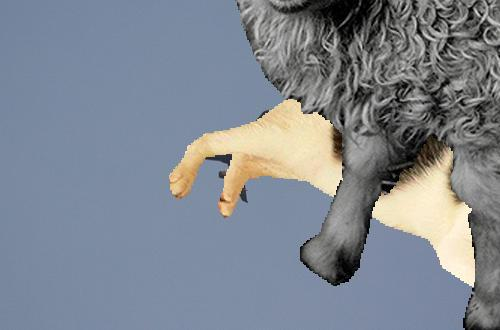What message might the creator be trying to convey with this image? Through this hybrid image of a sheep with hands for hooves, the creator might be evoking thoughts about genetic manipulation, the blending of species, or perhaps a humorous take on the phrase 'pulling the wool over someone's eyes.' It combines elements of reality and fantasy to provoke thought or amusement. 